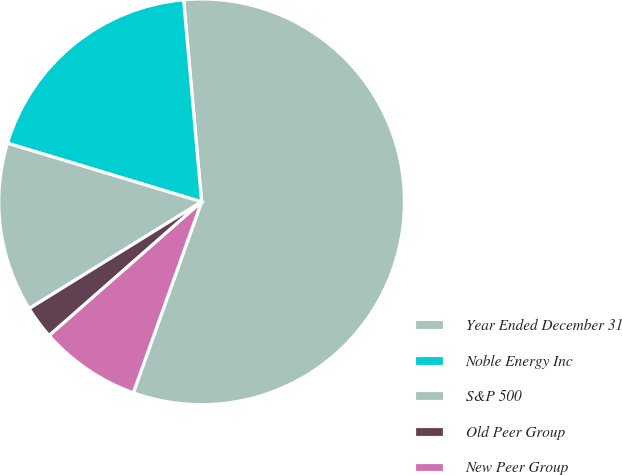<chart> <loc_0><loc_0><loc_500><loc_500><pie_chart><fcel>Year Ended December 31<fcel>Noble Energy Inc<fcel>S&P 500<fcel>Old Peer Group<fcel>New Peer Group<nl><fcel>56.88%<fcel>18.92%<fcel>13.49%<fcel>2.64%<fcel>8.07%<nl></chart> 